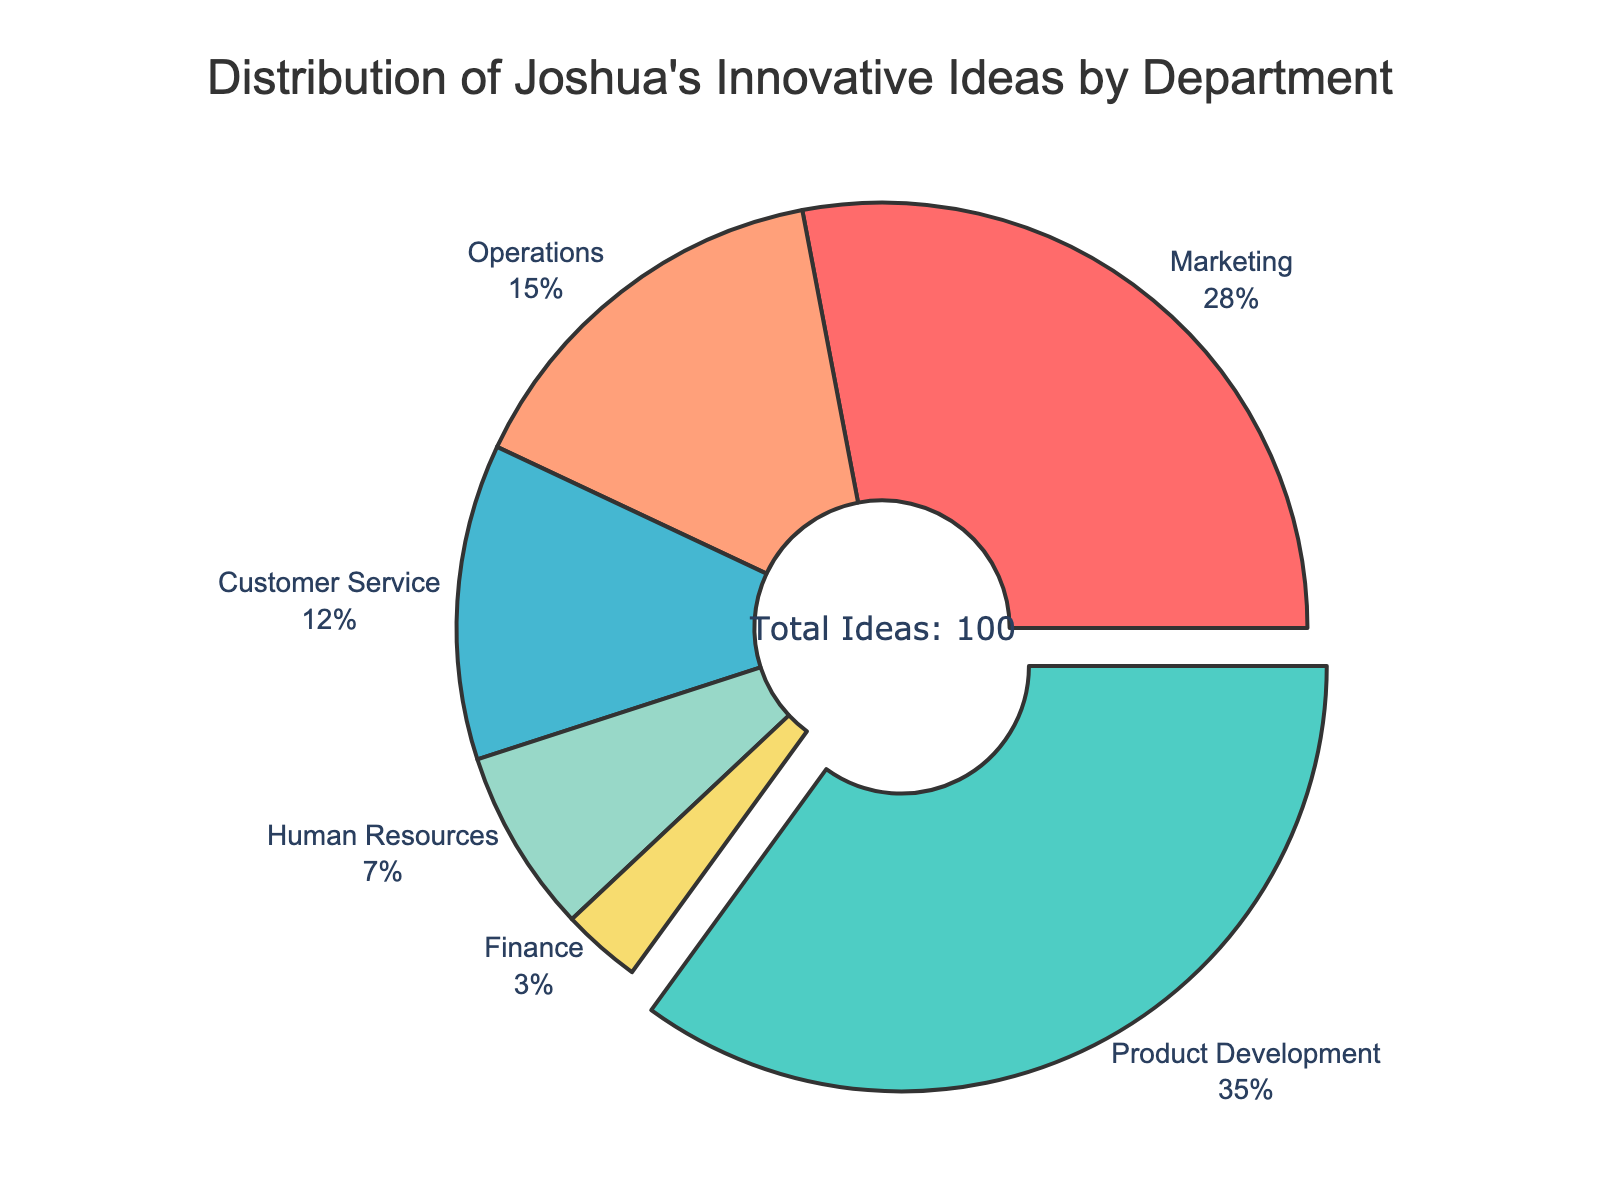Which department accounted for the largest percentage of Joshua's innovative ideas? The pie chart shows various departments with their respective percentages of Joshua's innovative ideas. The largest section visually is for Product Development.
Answer: Product Development How much larger is the percentage of innovative ideas in Marketing compared to Human Resources? According to the chart, Marketing accounts for 28% and Human Resources accounts for 7%. Subtracting the percentage of Human Resources from Marketing, 28% - 7% = 21%.
Answer: 21% What is the total percentage of Joshua's innovative ideas contributed by Operations and Product Development combined? The percentage for Operations is 15% and for Product Development is 35%. Adding these together, 15% + 35% = 50%.
Answer: 50% Which departmental category has the smallest share of Joshua's innovative ideas, and what percentage does it represent? The smallest section visible in the pie chart corresponds to Finance, which represents 3% of the total ideas.
Answer: Finance, 3% If the percentage of innovative ideas from Customer Service were to double, what would the new percentage be? Currently, Customer Service contributes 12%. Doubling this percentage, 12% * 2 = 24%.
Answer: 24% Are there more innovative ideas in Operations or Customer Service, and by what margin? Operations has 15% while Customer Service has 12%. The margin would be 15% - 12% = 3%.
Answer: Operations by 3% Is the distribution of innovative ideas more even across departments, or is there a significant concentration in one department? The pie chart indicates a significant concentration in Product Development, which is pulled out from the pie and represents the highest share at 35%. This suggests uneven distribution.
Answer: Significant concentration in Product Development Which color represents the Marketing department, and what percentage of Joshua's innovative ideas does it cover? According to the color scheme shown in the pie chart, the Marketing department is represented by the color red. It covers 28% of the ideas.
Answer: Red, 28% What is the sum of percentages for departments other than Product Development and Marketing? The percentages for departments other than Product Development (35%) and Marketing (28%) are: Customer Service (12%), Operations (15%), Human Resources (7%), and Finance (3%). Adding these together, 12% + 15% + 7% + 3% = 37%.
Answer: 37% 